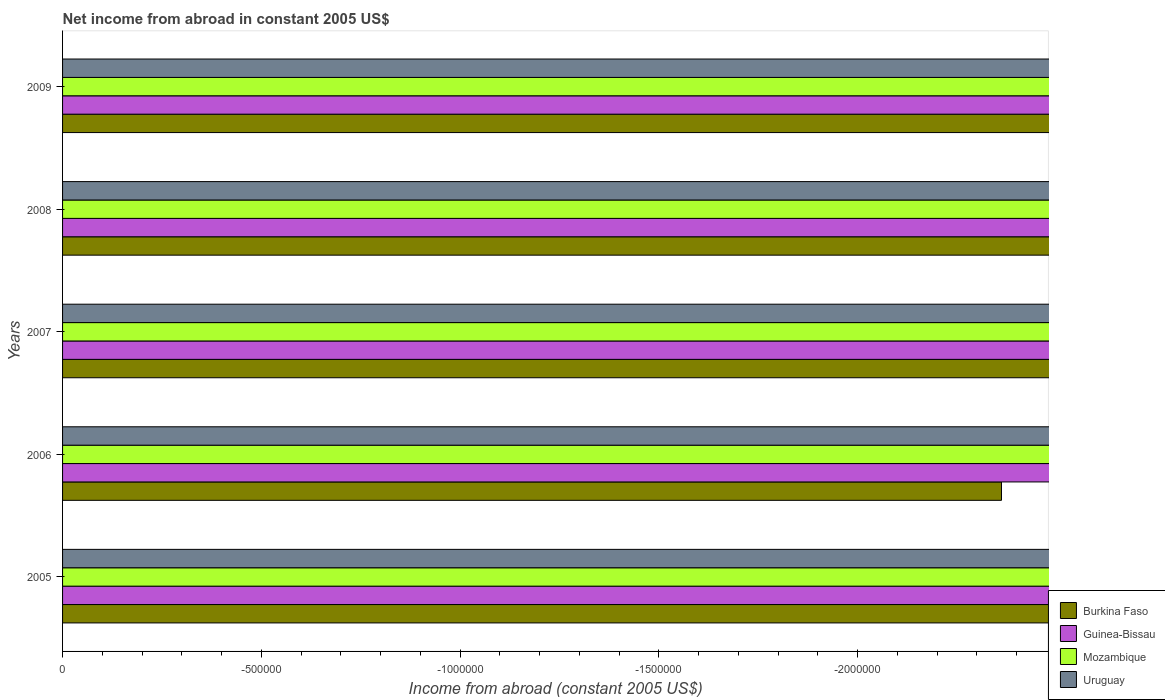How many different coloured bars are there?
Keep it short and to the point. 0. How many bars are there on the 3rd tick from the top?
Give a very brief answer. 0. What is the label of the 4th group of bars from the top?
Ensure brevity in your answer.  2006. In how many cases, is the number of bars for a given year not equal to the number of legend labels?
Your answer should be compact. 5. What is the net income from abroad in Guinea-Bissau in 2007?
Make the answer very short. 0. What is the difference between the net income from abroad in Burkina Faso in 2006 and the net income from abroad in Mozambique in 2008?
Provide a short and direct response. 0. In how many years, is the net income from abroad in Burkina Faso greater than -2200000 US$?
Provide a short and direct response. 0. In how many years, is the net income from abroad in Guinea-Bissau greater than the average net income from abroad in Guinea-Bissau taken over all years?
Provide a short and direct response. 0. Is it the case that in every year, the sum of the net income from abroad in Guinea-Bissau and net income from abroad in Uruguay is greater than the net income from abroad in Mozambique?
Your response must be concise. No. How many bars are there?
Your response must be concise. 0. How many years are there in the graph?
Ensure brevity in your answer.  5. Are the values on the major ticks of X-axis written in scientific E-notation?
Offer a very short reply. No. Does the graph contain any zero values?
Ensure brevity in your answer.  Yes. Does the graph contain grids?
Your answer should be compact. No. Where does the legend appear in the graph?
Provide a short and direct response. Bottom right. How are the legend labels stacked?
Your answer should be compact. Vertical. What is the title of the graph?
Your response must be concise. Net income from abroad in constant 2005 US$. Does "Cuba" appear as one of the legend labels in the graph?
Your answer should be very brief. No. What is the label or title of the X-axis?
Your answer should be compact. Income from abroad (constant 2005 US$). What is the label or title of the Y-axis?
Provide a short and direct response. Years. What is the Income from abroad (constant 2005 US$) of Mozambique in 2005?
Make the answer very short. 0. What is the Income from abroad (constant 2005 US$) of Burkina Faso in 2007?
Offer a very short reply. 0. What is the Income from abroad (constant 2005 US$) of Uruguay in 2007?
Ensure brevity in your answer.  0. What is the Income from abroad (constant 2005 US$) in Burkina Faso in 2008?
Ensure brevity in your answer.  0. What is the Income from abroad (constant 2005 US$) in Guinea-Bissau in 2008?
Keep it short and to the point. 0. What is the Income from abroad (constant 2005 US$) in Mozambique in 2008?
Your response must be concise. 0. What is the Income from abroad (constant 2005 US$) of Burkina Faso in 2009?
Give a very brief answer. 0. What is the Income from abroad (constant 2005 US$) in Uruguay in 2009?
Your response must be concise. 0. What is the total Income from abroad (constant 2005 US$) in Burkina Faso in the graph?
Make the answer very short. 0. What is the total Income from abroad (constant 2005 US$) in Mozambique in the graph?
Your answer should be compact. 0. What is the total Income from abroad (constant 2005 US$) in Uruguay in the graph?
Your answer should be very brief. 0. What is the average Income from abroad (constant 2005 US$) of Guinea-Bissau per year?
Keep it short and to the point. 0. What is the average Income from abroad (constant 2005 US$) of Mozambique per year?
Offer a very short reply. 0. 